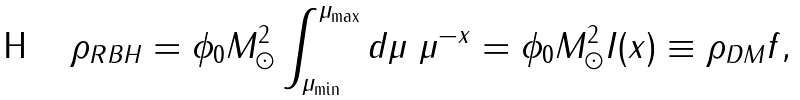<formula> <loc_0><loc_0><loc_500><loc_500>\rho _ { R B H } = \phi _ { 0 } M _ { \odot } ^ { 2 } \int _ { \mu _ { \min } } ^ { \mu _ { \max } } d \mu \ \mu ^ { - x } = \phi _ { 0 } M _ { \odot } ^ { 2 } I ( x ) \equiv \rho _ { D M } f ,</formula> 